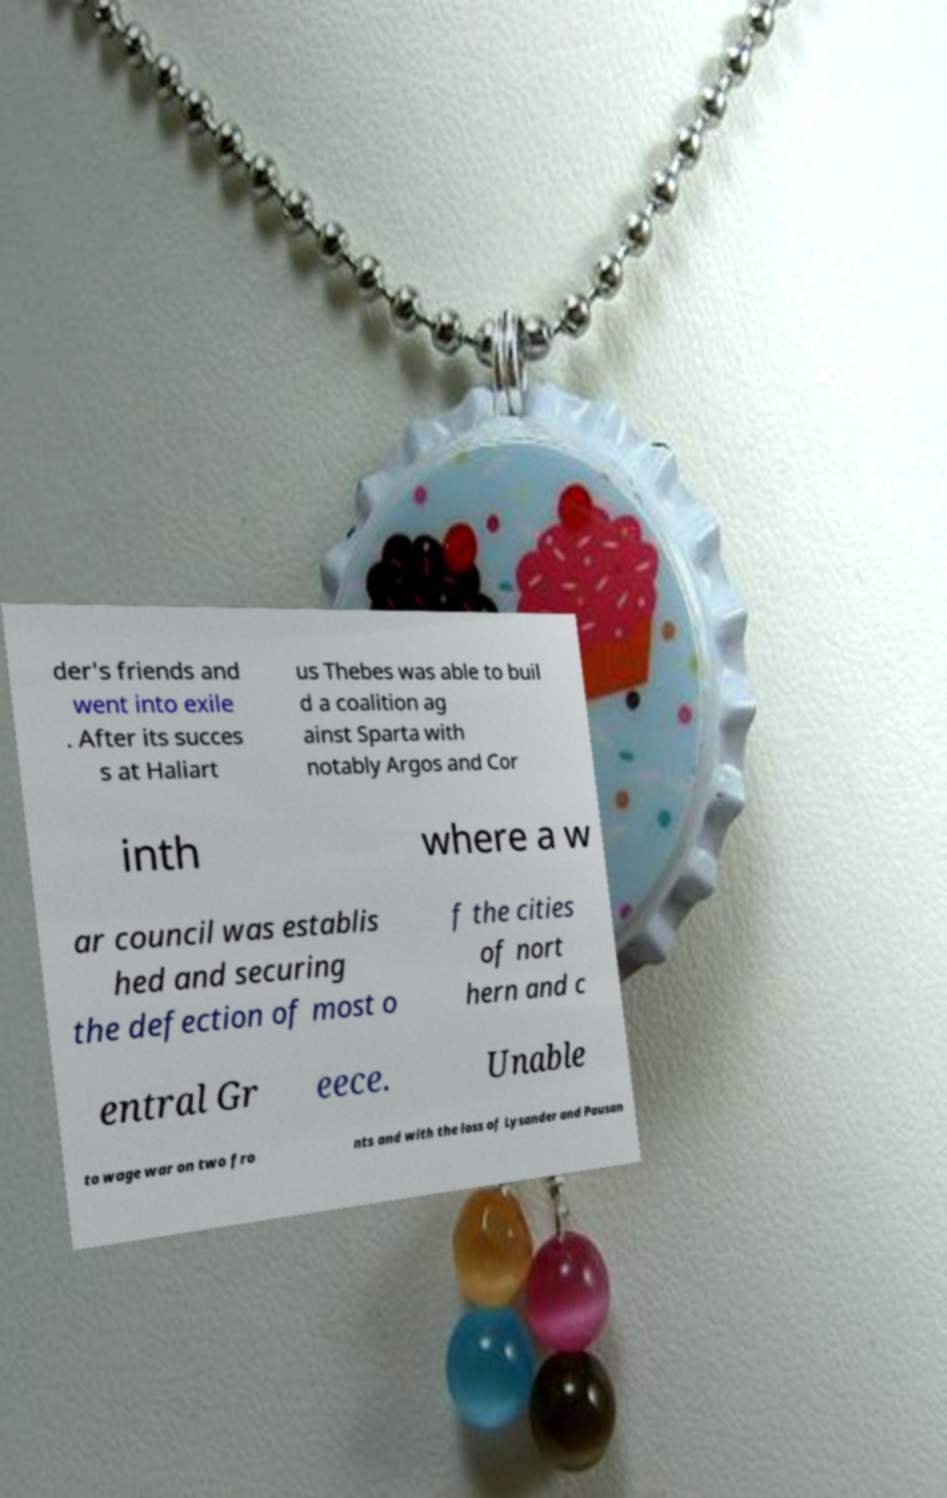For documentation purposes, I need the text within this image transcribed. Could you provide that? der's friends and went into exile . After its succes s at Haliart us Thebes was able to buil d a coalition ag ainst Sparta with notably Argos and Cor inth where a w ar council was establis hed and securing the defection of most o f the cities of nort hern and c entral Gr eece. Unable to wage war on two fro nts and with the loss of Lysander and Pausan 